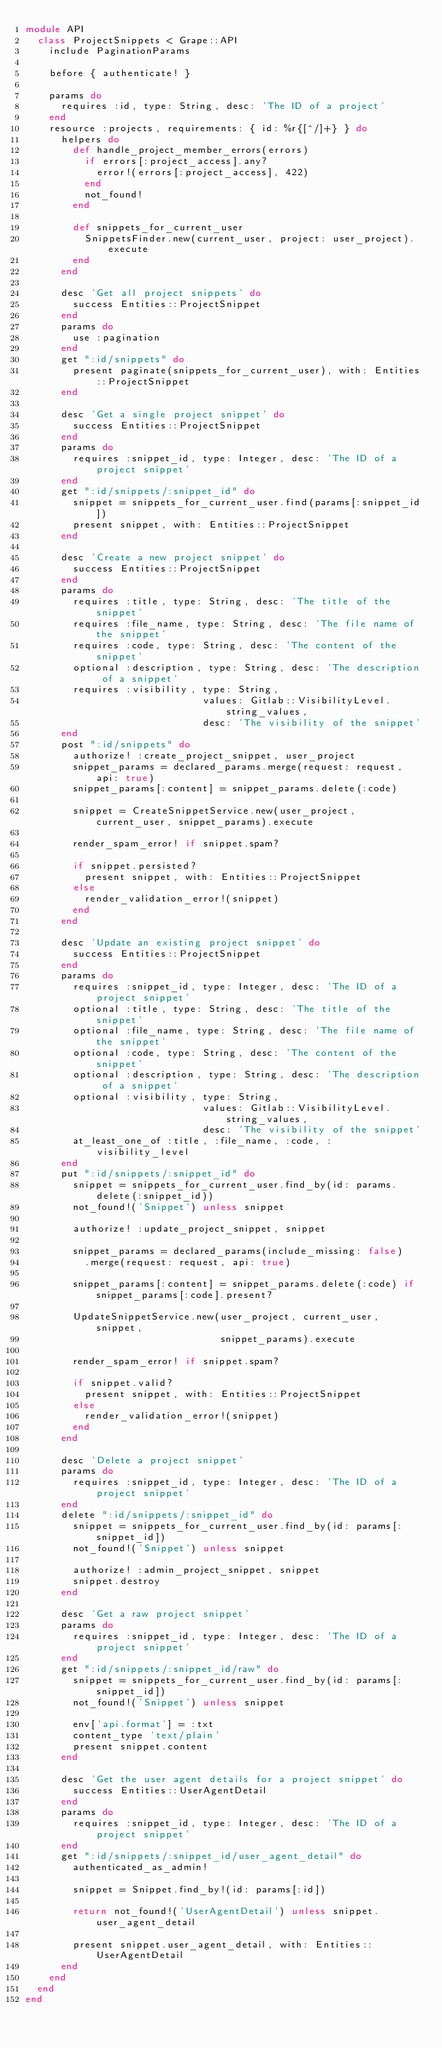Convert code to text. <code><loc_0><loc_0><loc_500><loc_500><_Ruby_>module API
  class ProjectSnippets < Grape::API
    include PaginationParams

    before { authenticate! }

    params do
      requires :id, type: String, desc: 'The ID of a project'
    end
    resource :projects, requirements: { id: %r{[^/]+} } do
      helpers do
        def handle_project_member_errors(errors)
          if errors[:project_access].any?
            error!(errors[:project_access], 422)
          end
          not_found!
        end

        def snippets_for_current_user
          SnippetsFinder.new(current_user, project: user_project).execute
        end
      end

      desc 'Get all project snippets' do
        success Entities::ProjectSnippet
      end
      params do
        use :pagination
      end
      get ":id/snippets" do
        present paginate(snippets_for_current_user), with: Entities::ProjectSnippet
      end

      desc 'Get a single project snippet' do
        success Entities::ProjectSnippet
      end
      params do
        requires :snippet_id, type: Integer, desc: 'The ID of a project snippet'
      end
      get ":id/snippets/:snippet_id" do
        snippet = snippets_for_current_user.find(params[:snippet_id])
        present snippet, with: Entities::ProjectSnippet
      end

      desc 'Create a new project snippet' do
        success Entities::ProjectSnippet
      end
      params do
        requires :title, type: String, desc: 'The title of the snippet'
        requires :file_name, type: String, desc: 'The file name of the snippet'
        requires :code, type: String, desc: 'The content of the snippet'
        optional :description, type: String, desc: 'The description of a snippet'
        requires :visibility, type: String,
                              values: Gitlab::VisibilityLevel.string_values,
                              desc: 'The visibility of the snippet'
      end
      post ":id/snippets" do
        authorize! :create_project_snippet, user_project
        snippet_params = declared_params.merge(request: request, api: true)
        snippet_params[:content] = snippet_params.delete(:code)

        snippet = CreateSnippetService.new(user_project, current_user, snippet_params).execute

        render_spam_error! if snippet.spam?

        if snippet.persisted?
          present snippet, with: Entities::ProjectSnippet
        else
          render_validation_error!(snippet)
        end
      end

      desc 'Update an existing project snippet' do
        success Entities::ProjectSnippet
      end
      params do
        requires :snippet_id, type: Integer, desc: 'The ID of a project snippet'
        optional :title, type: String, desc: 'The title of the snippet'
        optional :file_name, type: String, desc: 'The file name of the snippet'
        optional :code, type: String, desc: 'The content of the snippet'
        optional :description, type: String, desc: 'The description of a snippet'
        optional :visibility, type: String,
                              values: Gitlab::VisibilityLevel.string_values,
                              desc: 'The visibility of the snippet'
        at_least_one_of :title, :file_name, :code, :visibility_level
      end
      put ":id/snippets/:snippet_id" do
        snippet = snippets_for_current_user.find_by(id: params.delete(:snippet_id))
        not_found!('Snippet') unless snippet

        authorize! :update_project_snippet, snippet

        snippet_params = declared_params(include_missing: false)
          .merge(request: request, api: true)

        snippet_params[:content] = snippet_params.delete(:code) if snippet_params[:code].present?

        UpdateSnippetService.new(user_project, current_user, snippet,
                                 snippet_params).execute

        render_spam_error! if snippet.spam?

        if snippet.valid?
          present snippet, with: Entities::ProjectSnippet
        else
          render_validation_error!(snippet)
        end
      end

      desc 'Delete a project snippet'
      params do
        requires :snippet_id, type: Integer, desc: 'The ID of a project snippet'
      end
      delete ":id/snippets/:snippet_id" do
        snippet = snippets_for_current_user.find_by(id: params[:snippet_id])
        not_found!('Snippet') unless snippet

        authorize! :admin_project_snippet, snippet
        snippet.destroy
      end

      desc 'Get a raw project snippet'
      params do
        requires :snippet_id, type: Integer, desc: 'The ID of a project snippet'
      end
      get ":id/snippets/:snippet_id/raw" do
        snippet = snippets_for_current_user.find_by(id: params[:snippet_id])
        not_found!('Snippet') unless snippet

        env['api.format'] = :txt
        content_type 'text/plain'
        present snippet.content
      end

      desc 'Get the user agent details for a project snippet' do
        success Entities::UserAgentDetail
      end
      params do
        requires :snippet_id, type: Integer, desc: 'The ID of a project snippet'
      end
      get ":id/snippets/:snippet_id/user_agent_detail" do
        authenticated_as_admin!

        snippet = Snippet.find_by!(id: params[:id])

        return not_found!('UserAgentDetail') unless snippet.user_agent_detail

        present snippet.user_agent_detail, with: Entities::UserAgentDetail
      end
    end
  end
end
</code> 